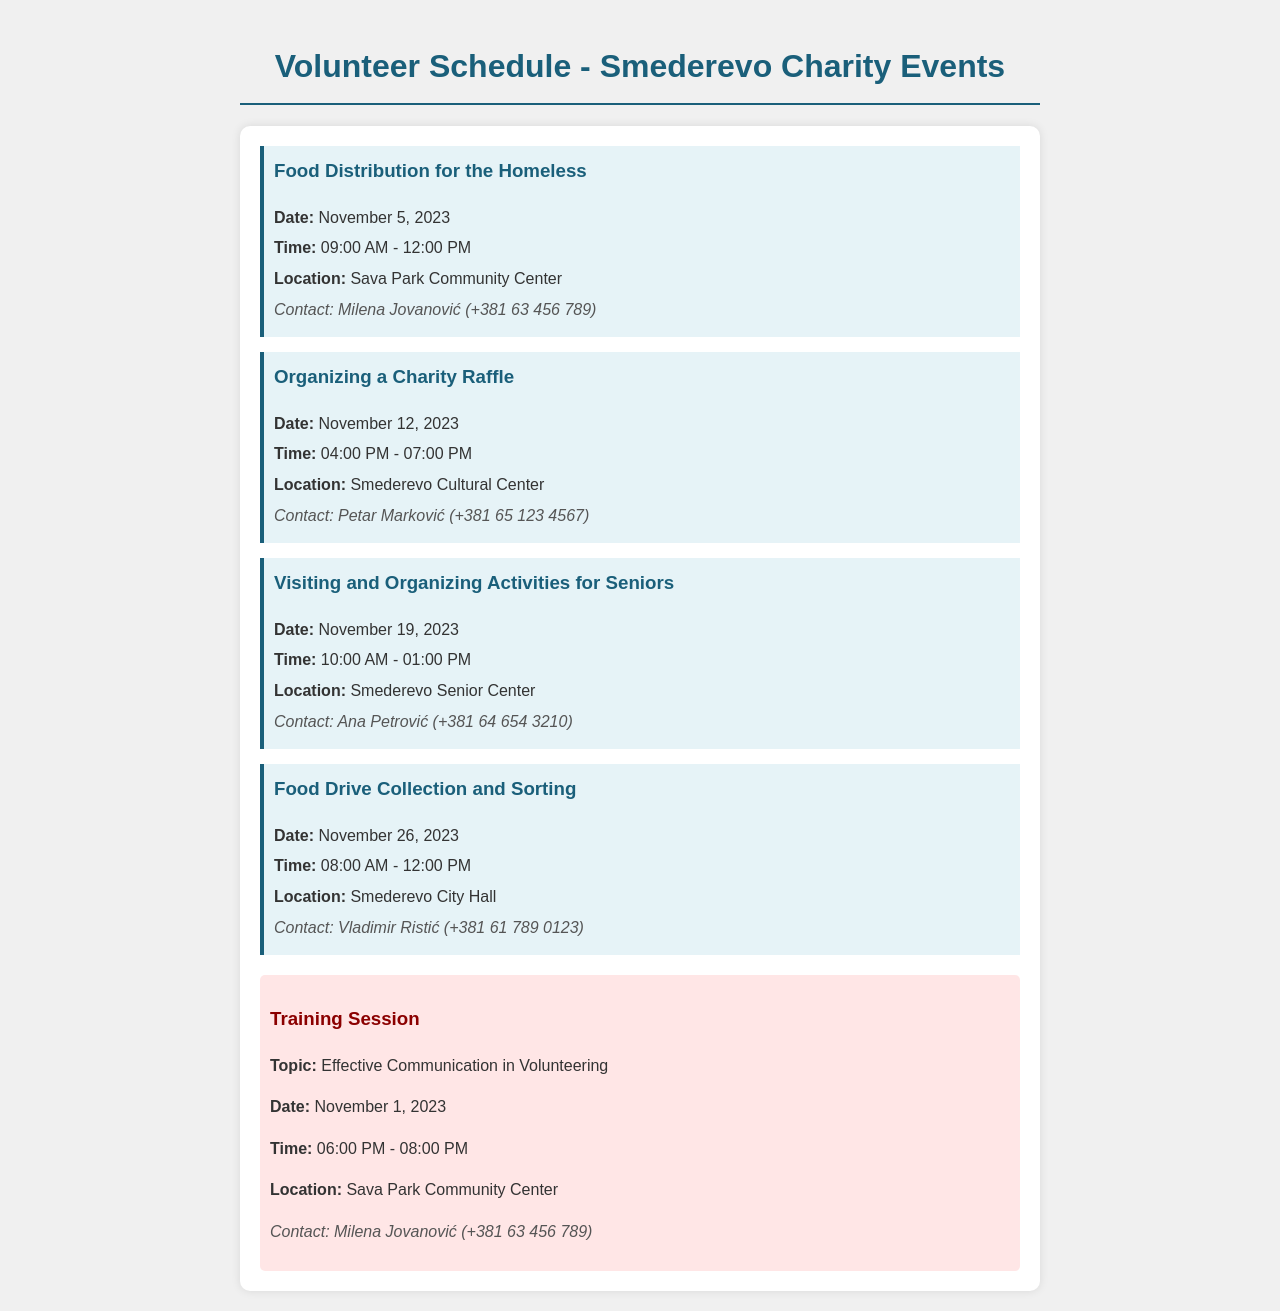What is the first event listed? The first event listed in the schedule is "Food Distribution for the Homeless."
Answer: Food Distribution for the Homeless When is the food drive collection scheduled? The food drive collection is scheduled for November 26, 2023.
Answer: November 26, 2023 What time does the charity raffle start? The charity raffle starts at 04:00 PM.
Answer: 04:00 PM Who should I contact for the activities for seniors? The contact person for the activities for seniors is Ana Petrović.
Answer: Ana Petrović How many events are scheduled for November? There are four events scheduled for November.
Answer: Four What is the location of the training session? The location of the training session is Sava Park Community Center.
Answer: Sava Park Community Center What is the contact number for the food distribution event? The contact number for the food distribution event is +381 63 456 789.
Answer: +381 63 456 789 What topic is covered in the training session? The topic covered in the training session is "Effective Communication in Volunteering."
Answer: Effective Communication in Volunteering What is the duration of the food drive collection? The food drive collection lasts from 08:00 AM to 12:00 PM.
Answer: 08:00 AM - 12:00 PM 